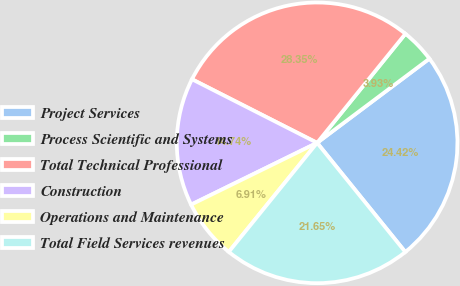<chart> <loc_0><loc_0><loc_500><loc_500><pie_chart><fcel>Project Services<fcel>Process Scientific and Systems<fcel>Total Technical Professional<fcel>Construction<fcel>Operations and Maintenance<fcel>Total Field Services revenues<nl><fcel>24.42%<fcel>3.93%<fcel>28.35%<fcel>14.74%<fcel>6.91%<fcel>21.65%<nl></chart> 